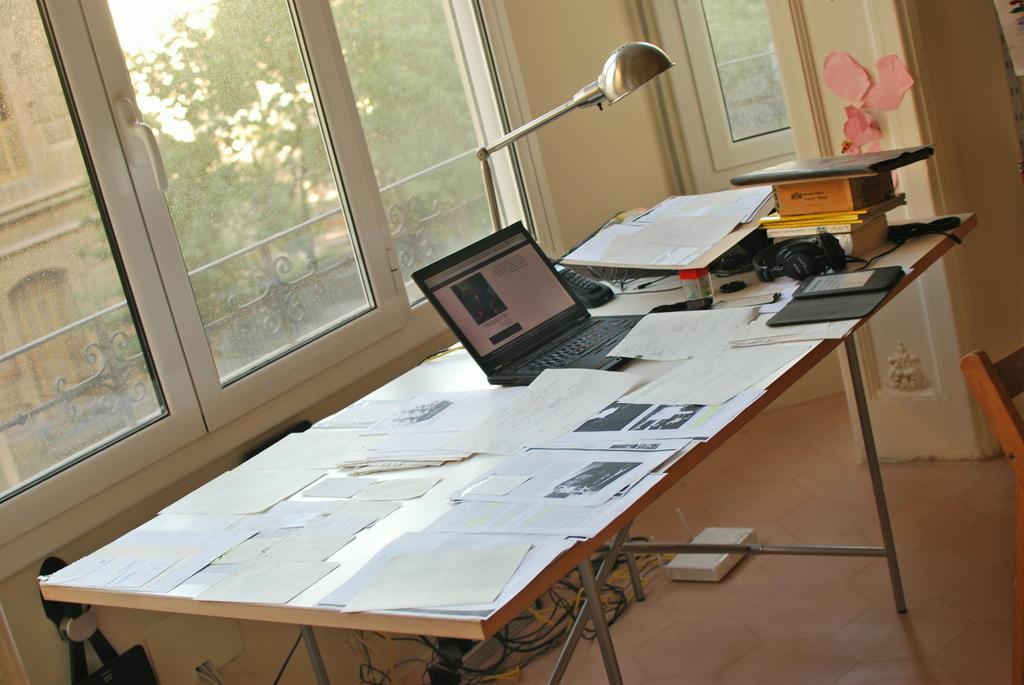Describe this image in one or two sentences. In this image we can see papers, laptop, table light, books,headsets and mobile phone on the table. In the background we can see glass windows through which we can see trees and buildings. 